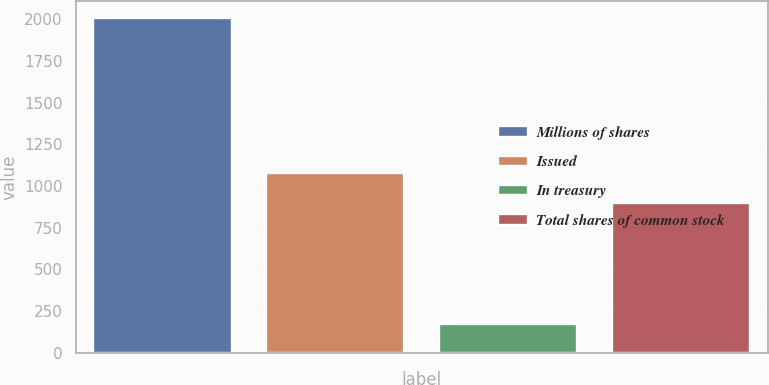Convert chart. <chart><loc_0><loc_0><loc_500><loc_500><bar_chart><fcel>Millions of shares<fcel>Issued<fcel>In treasury<fcel>Total shares of common stock<nl><fcel>2008<fcel>1078.6<fcel>172<fcel>895<nl></chart> 